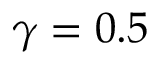Convert formula to latex. <formula><loc_0><loc_0><loc_500><loc_500>\gamma = 0 . 5</formula> 